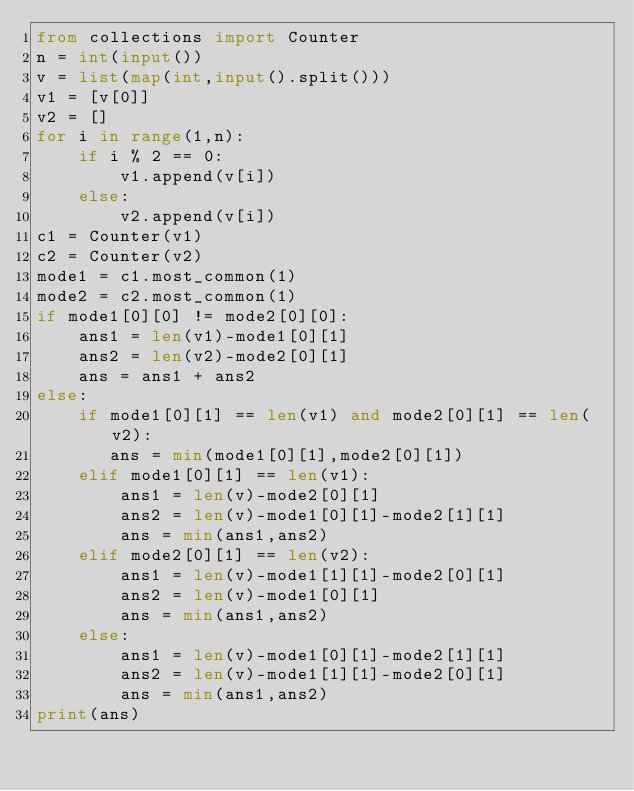Convert code to text. <code><loc_0><loc_0><loc_500><loc_500><_Python_>from collections import Counter
n = int(input())
v = list(map(int,input().split()))
v1 = [v[0]]
v2 = []
for i in range(1,n):
    if i % 2 == 0:
        v1.append(v[i])
    else:
        v2.append(v[i])
c1 = Counter(v1)
c2 = Counter(v2)
mode1 = c1.most_common(1)
mode2 = c2.most_common(1)
if mode1[0][0] != mode2[0][0]:
    ans1 = len(v1)-mode1[0][1]
    ans2 = len(v2)-mode2[0][1]
    ans = ans1 + ans2
else:
    if mode1[0][1] == len(v1) and mode2[0][1] == len(v2):
       ans = min(mode1[0][1],mode2[0][1])
    elif mode1[0][1] == len(v1):
        ans1 = len(v)-mode2[0][1]
        ans2 = len(v)-mode1[0][1]-mode2[1][1]
        ans = min(ans1,ans2)
    elif mode2[0][1] == len(v2):
        ans1 = len(v)-mode1[1][1]-mode2[0][1]  
        ans2 = len(v)-mode1[0][1]
        ans = min(ans1,ans2)
    else:
        ans1 = len(v)-mode1[0][1]-mode2[1][1]
        ans2 = len(v)-mode1[1][1]-mode2[0][1]
        ans = min(ans1,ans2)
print(ans)</code> 